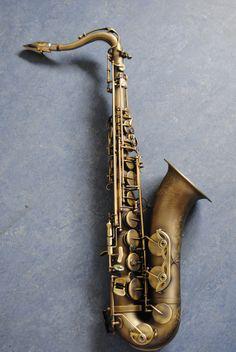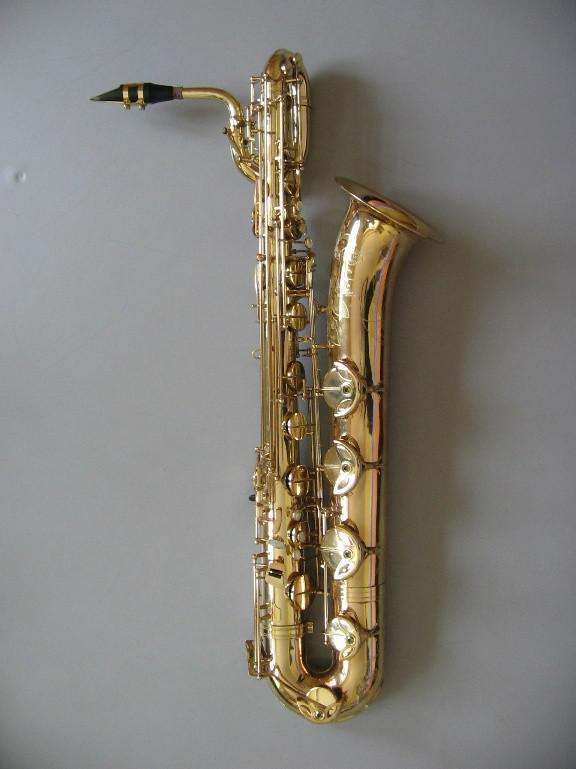The first image is the image on the left, the second image is the image on the right. For the images shown, is this caption "An image shows one saxophone that seems to be standing up on a flat ground, instead of lying flat or floating." true? Answer yes or no. No. 